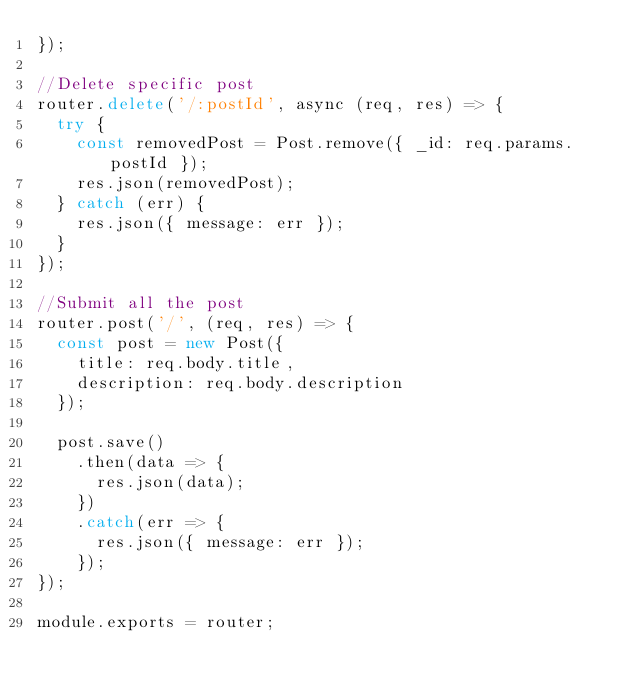Convert code to text. <code><loc_0><loc_0><loc_500><loc_500><_JavaScript_>});

//Delete specific post
router.delete('/:postId', async (req, res) => {
  try {
    const removedPost = Post.remove({ _id: req.params.postId });
    res.json(removedPost);
  } catch (err) {
    res.json({ message: err });
  }
});

//Submit all the post
router.post('/', (req, res) => {
  const post = new Post({
    title: req.body.title,
    description: req.body.description
  });

  post.save()
    .then(data => {
      res.json(data);
    })
    .catch(err => {
      res.json({ message: err });
    });
});

module.exports = router;
</code> 